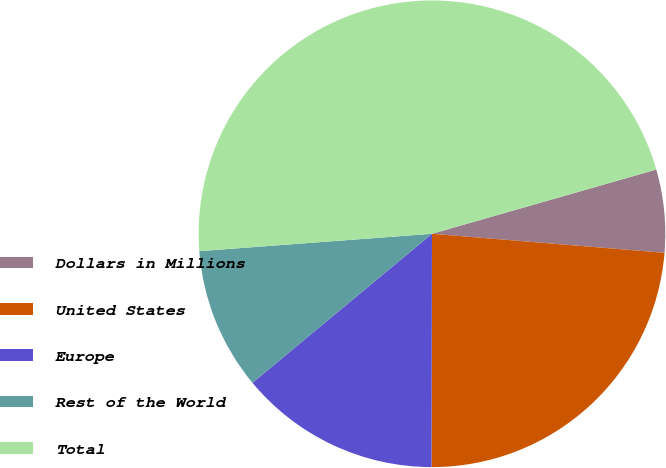<chart> <loc_0><loc_0><loc_500><loc_500><pie_chart><fcel>Dollars in Millions<fcel>United States<fcel>Europe<fcel>Rest of the World<fcel>Total<nl><fcel>5.74%<fcel>23.73%<fcel>13.94%<fcel>9.84%<fcel>46.74%<nl></chart> 